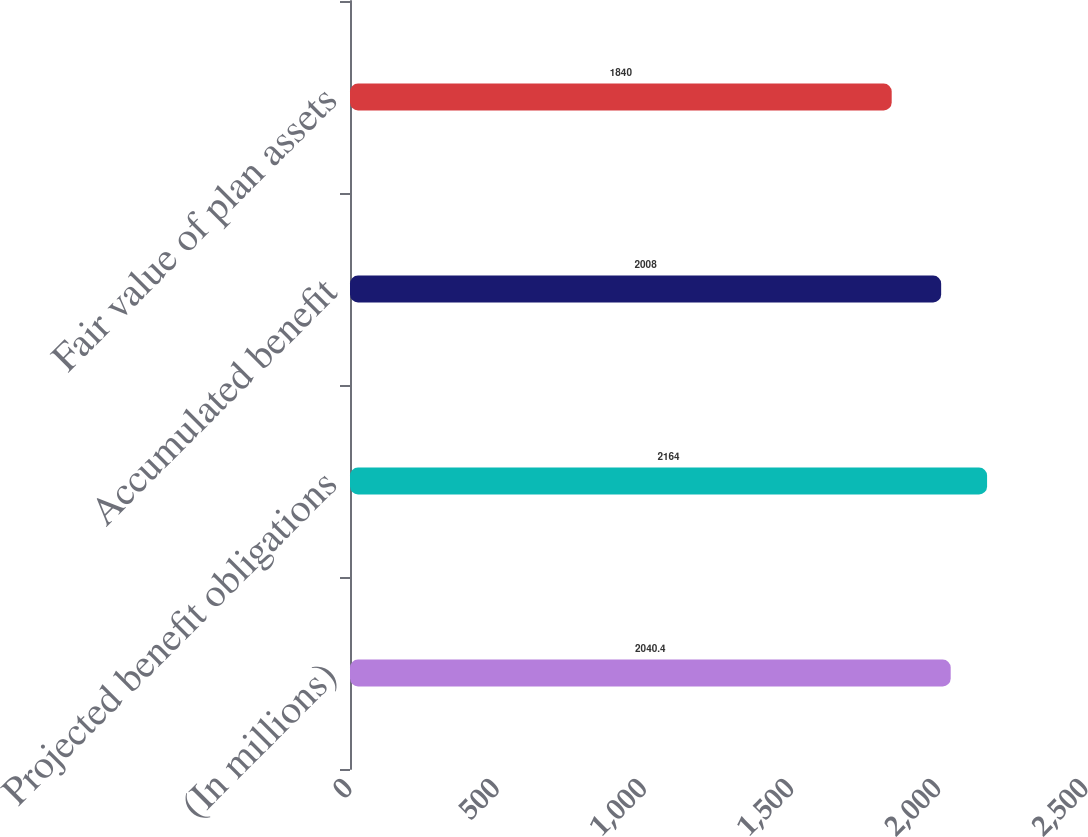Convert chart. <chart><loc_0><loc_0><loc_500><loc_500><bar_chart><fcel>(In millions)<fcel>Projected benefit obligations<fcel>Accumulated benefit<fcel>Fair value of plan assets<nl><fcel>2040.4<fcel>2164<fcel>2008<fcel>1840<nl></chart> 